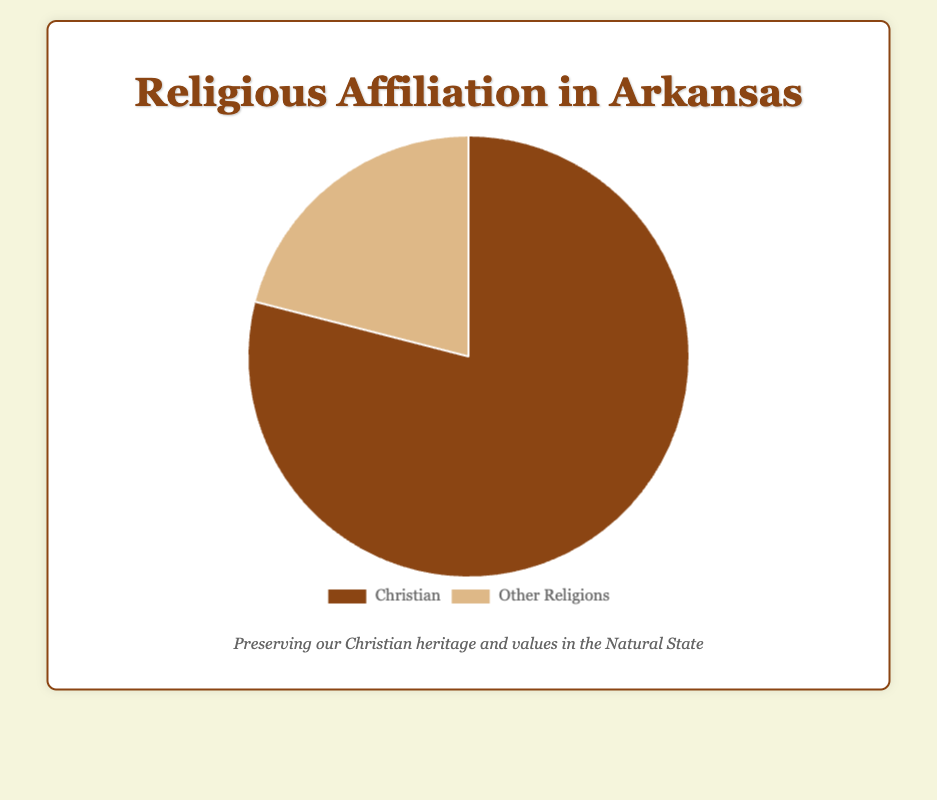What percentage of people in Arkansas identify as Christians? The chart shows that the percentage of people identifying as Christians is represented by the larger portion of the pie chart. The exact value is provided in the data as 79%.
Answer: 79% What is the percentage of people affiliated with religions other than Christianity in Arkansas? The chart represents the percentage of people with religious affiliations other than Christianity as the smaller portion of the pie chart. The exact value is given as 21%.
Answer: 21% By how much does the percentage of Christians exceed the percentage of other religions in Arkansas? We need to subtract the percentage of people with other religious affiliations (21%) from the percentage of people who identify as Christians (79%). So, 79% - 21% = 58%.
Answer: 58% What is the ratio of Christians to people of other religions in Arkansas? To find the ratio, divide the percentage of Christians by the percentage of other religions: 79 / 21. This simplifies to approximately 3.76 to 1.
Answer: 3.76:1 Which religious affiliation is represented by the brown color in the pie chart? The brown color represents Christians, as it corresponds to the larger segment, which is labeled as Christian with 79%.
Answer: Christian Which segment of the pie chart is larger, the one representing Christians or the one representing other religions? Visually, the segment representing Christians is larger than the segment representing other religions.
Answer: Christians If the total population of Arkansas were 3 million, how many people would identify as Christians based on this chart? We need to calculate 79% of 3 million. 3,000,000 * 0.79 = 2,370,000. So, 2,370,000 people would identify as Christians.
Answer: 2,370,000 How does the visual size of the segment representing Christians compare to the size of the segment representing other religions? The segment representing Christians is significantly larger than the segment representing other religions, which can be seen by the larger area it occupies on the pie chart.
Answer: Larger If you were to combine the percentages of Christians and other religions, what total percentage would you get? Adding the percentages of the two segments: 79% (Christians) + 21% (Other Religions) equals 100%.
Answer: 100% Based on the chart, can you determine which religious affiliation is most prevalent in Arkansas? By observing the larger segment and its associated label, it's clear that Christianity is the most prevalent religious affiliation in Arkansas.
Answer: Christianity 